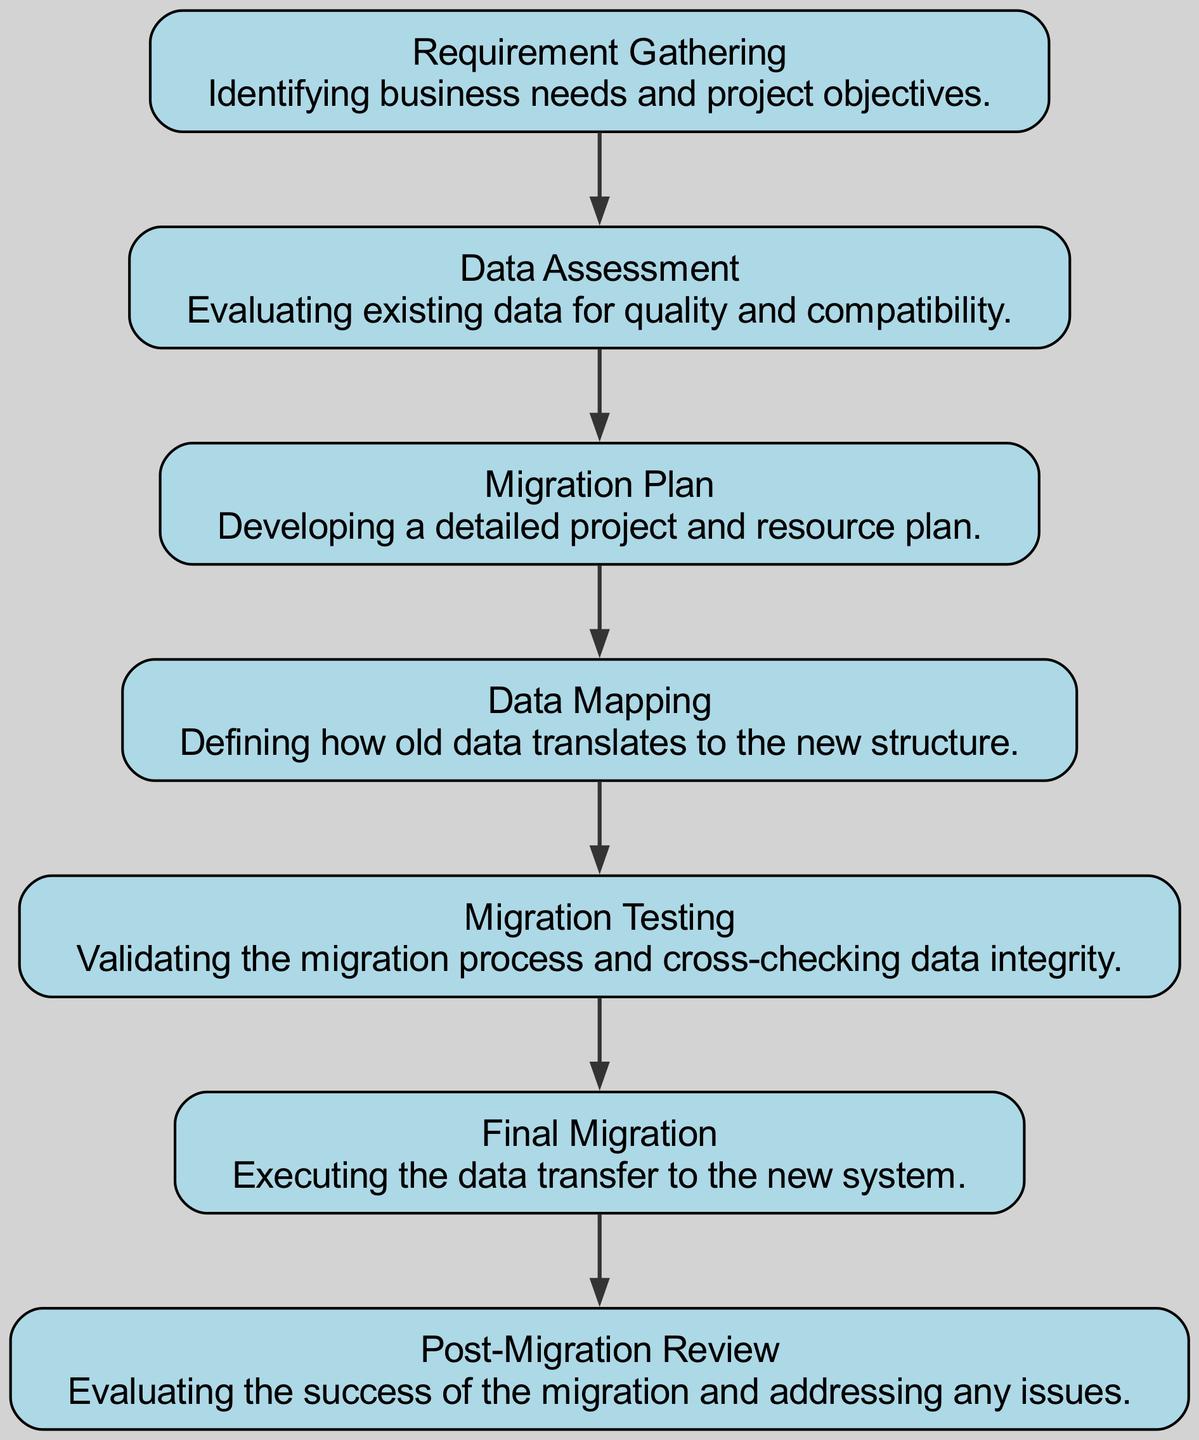What is the first milestone in the data migration process? The first node listed is "Requirement Gathering," which signifies the beginning of the process where business needs are identified.
Answer: Requirement Gathering How many nodes are present in the diagram? By counting the nodes listed, we can identify there are seven unique milestones present throughout the migration process.
Answer: 7 What is the last milestone completed in the process? The final node shown is "Post-Migration Review," which indicates the last step taken after the migration is complete for evaluation.
Answer: Post-Migration Review What is the relationship between "Data Mapping" and "Migration Testing"? The directed edge connects "Data Mapping" directly to "Migration Testing," indicating that Migration Testing cannot occur until Data Mapping is complete.
Answer: Data Mapping → Migration Testing What is the total number of edges in the graph? By examining the edges provided, it can be determined that there are six directed edges showing the relationship between the milestones.
Answer: 6 Which milestone directly follows "Final Migration"? The directed edge leads from "Final Migration" to "Post-Migration Review," indicating that it is the immediate next step after the final migration.
Answer: Post-Migration Review What step must occur before the "Data Mapping" process can begin? The edge from "Migration Plan" to "Data Mapping" illustrates that the migration plan must be laid out prior to proceeding with data mapping.
Answer: Migration Plan Which milestone indicates the evaluation phase of the data migration? The last node, "Post-Migration Review," signifies the evaluation phase where the success of the migration is reviewed and issues are addressed.
Answer: Post-Migration Review What is the purpose of the "Data Assessment" milestone? This milestone serves the purpose of evaluating existing data to ensure its quality and compatibility for the migration initiative.
Answer: Evaluating existing data What must happen after "Migration Testing" is complete? Following "Migration Testing," the next step as indicated by the directional flow is "Final Migration."
Answer: Final Migration 